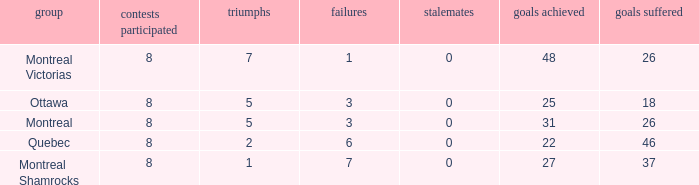For teams with 7 wins, what is the number of goals against? 26.0. Could you parse the entire table? {'header': ['group', 'contests participated', 'triumphs', 'failures', 'stalemates', 'goals achieved', 'goals suffered'], 'rows': [['Montreal Victorias', '8', '7', '1', '0', '48', '26'], ['Ottawa', '8', '5', '3', '0', '25', '18'], ['Montreal', '8', '5', '3', '0', '31', '26'], ['Quebec', '8', '2', '6', '0', '22', '46'], ['Montreal Shamrocks', '8', '1', '7', '0', '27', '37']]} 